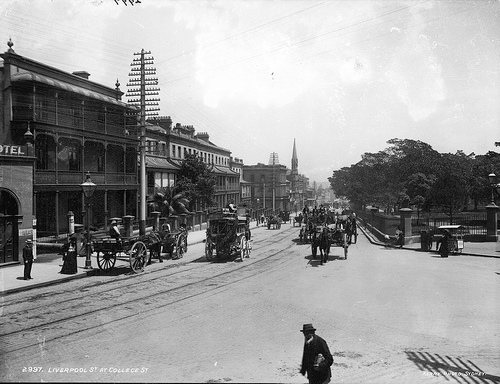Identify the text contained in this image. OTEL 